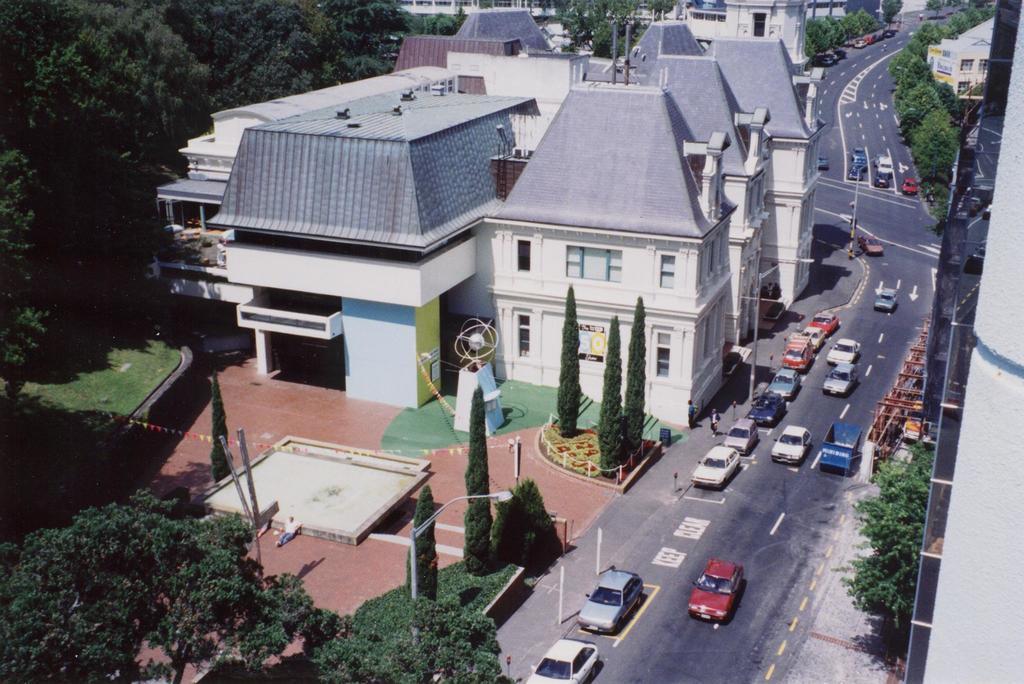Can you describe this image briefly? In this image we can see some vehicles on the road and some houses with roof and windows. We can also see some trees, plants and a street pole. 